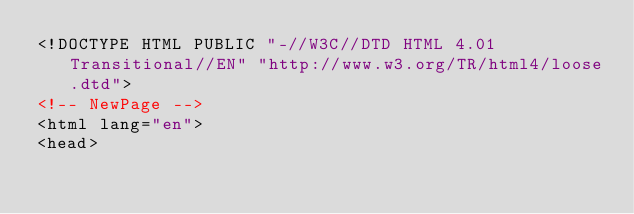Convert code to text. <code><loc_0><loc_0><loc_500><loc_500><_HTML_><!DOCTYPE HTML PUBLIC "-//W3C//DTD HTML 4.01 Transitional//EN" "http://www.w3.org/TR/html4/loose.dtd">
<!-- NewPage -->
<html lang="en">
<head></code> 